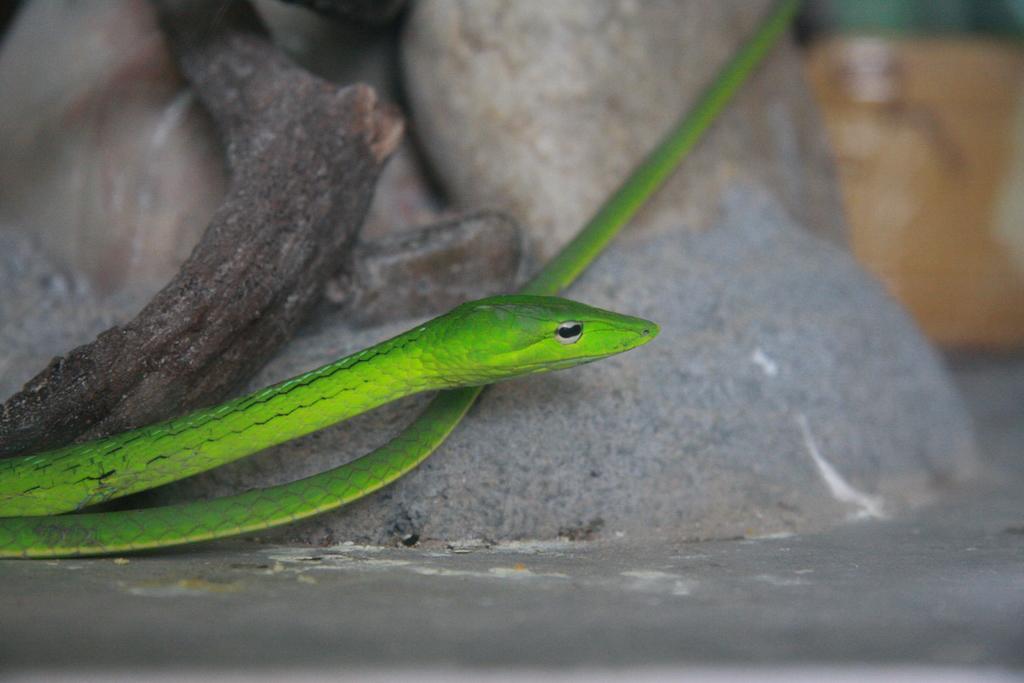Please provide a concise description of this image. There is a green color snake in the center of the image, it seems like branch and stones in the background area. 